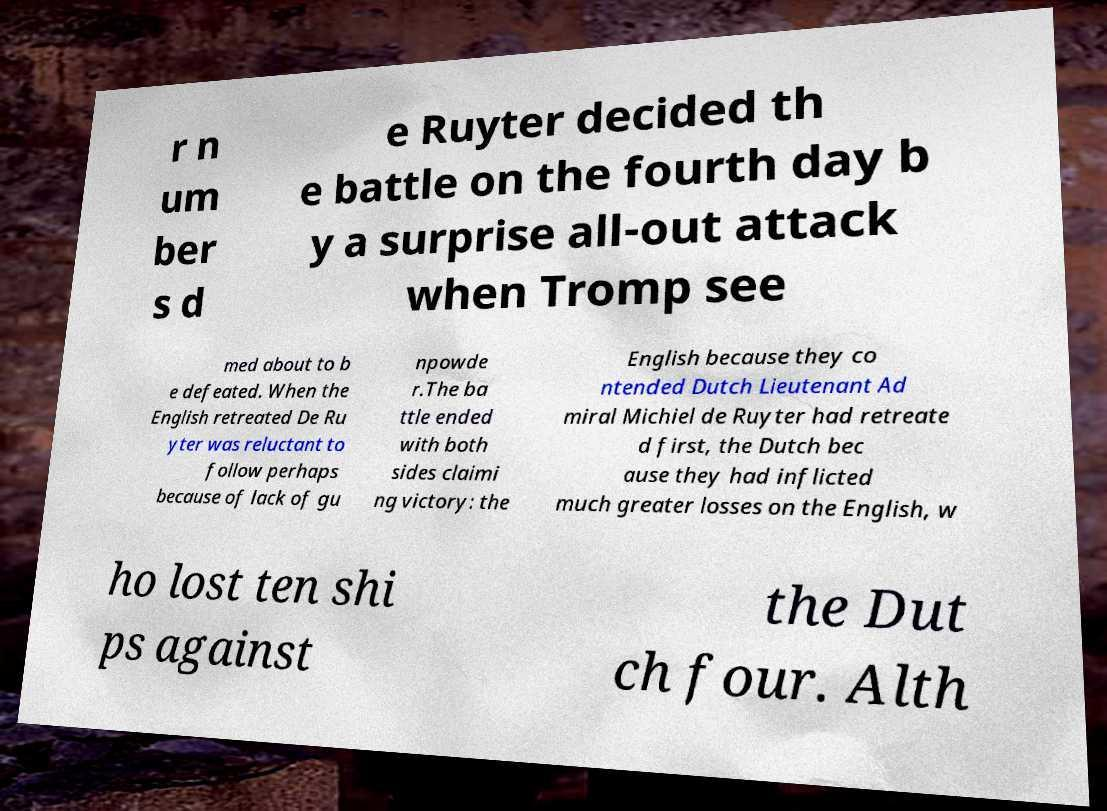Could you extract and type out the text from this image? r n um ber s d e Ruyter decided th e battle on the fourth day b y a surprise all-out attack when Tromp see med about to b e defeated. When the English retreated De Ru yter was reluctant to follow perhaps because of lack of gu npowde r.The ba ttle ended with both sides claimi ng victory: the English because they co ntended Dutch Lieutenant Ad miral Michiel de Ruyter had retreate d first, the Dutch bec ause they had inflicted much greater losses on the English, w ho lost ten shi ps against the Dut ch four. Alth 